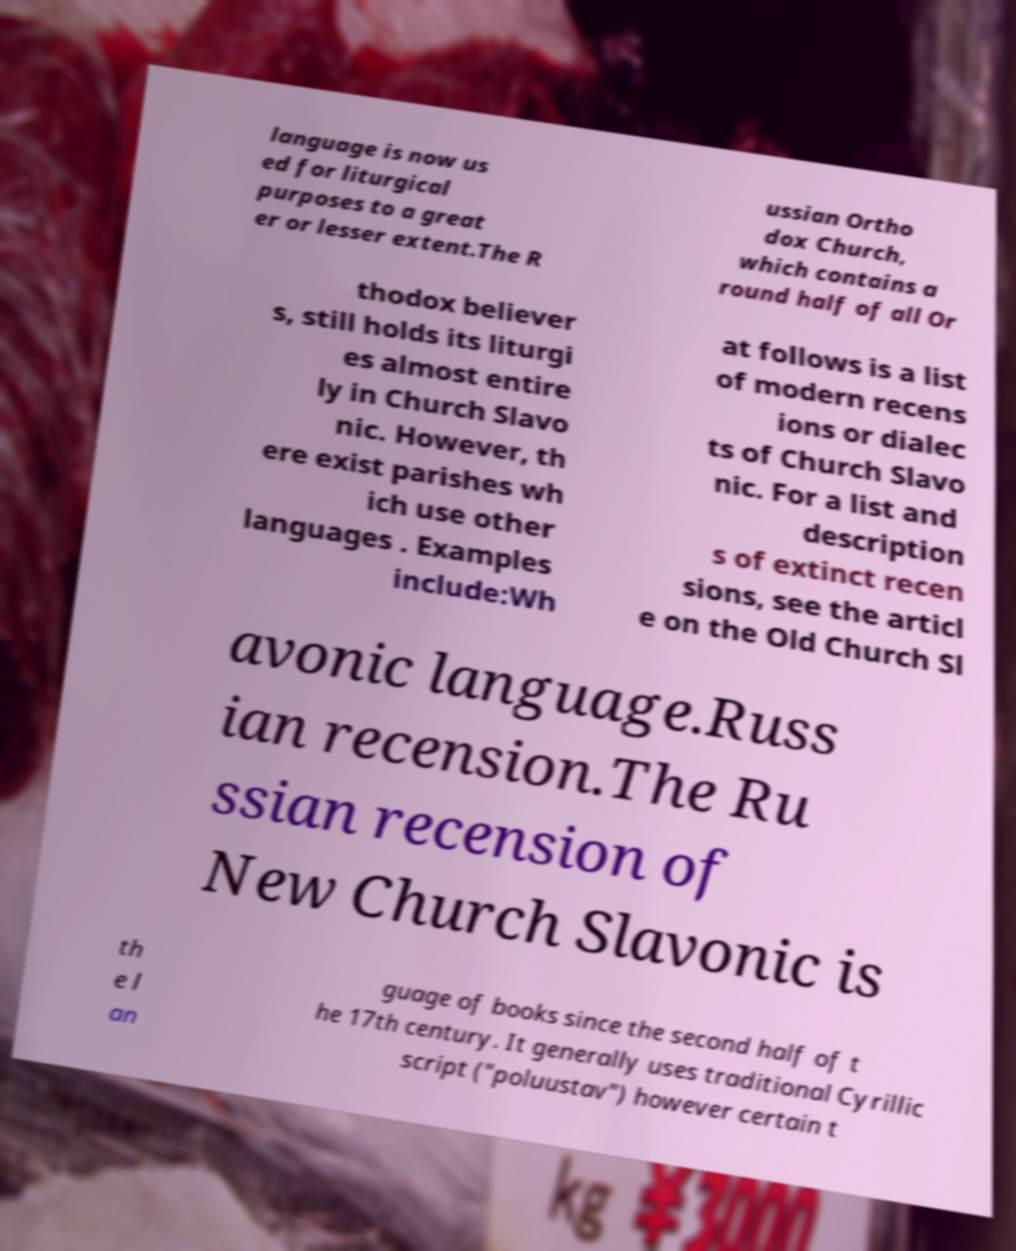Can you read and provide the text displayed in the image?This photo seems to have some interesting text. Can you extract and type it out for me? language is now us ed for liturgical purposes to a great er or lesser extent.The R ussian Ortho dox Church, which contains a round half of all Or thodox believer s, still holds its liturgi es almost entire ly in Church Slavo nic. However, th ere exist parishes wh ich use other languages . Examples include:Wh at follows is a list of modern recens ions or dialec ts of Church Slavo nic. For a list and description s of extinct recen sions, see the articl e on the Old Church Sl avonic language.Russ ian recension.The Ru ssian recension of New Church Slavonic is th e l an guage of books since the second half of t he 17th century. It generally uses traditional Cyrillic script ("poluustav") however certain t 